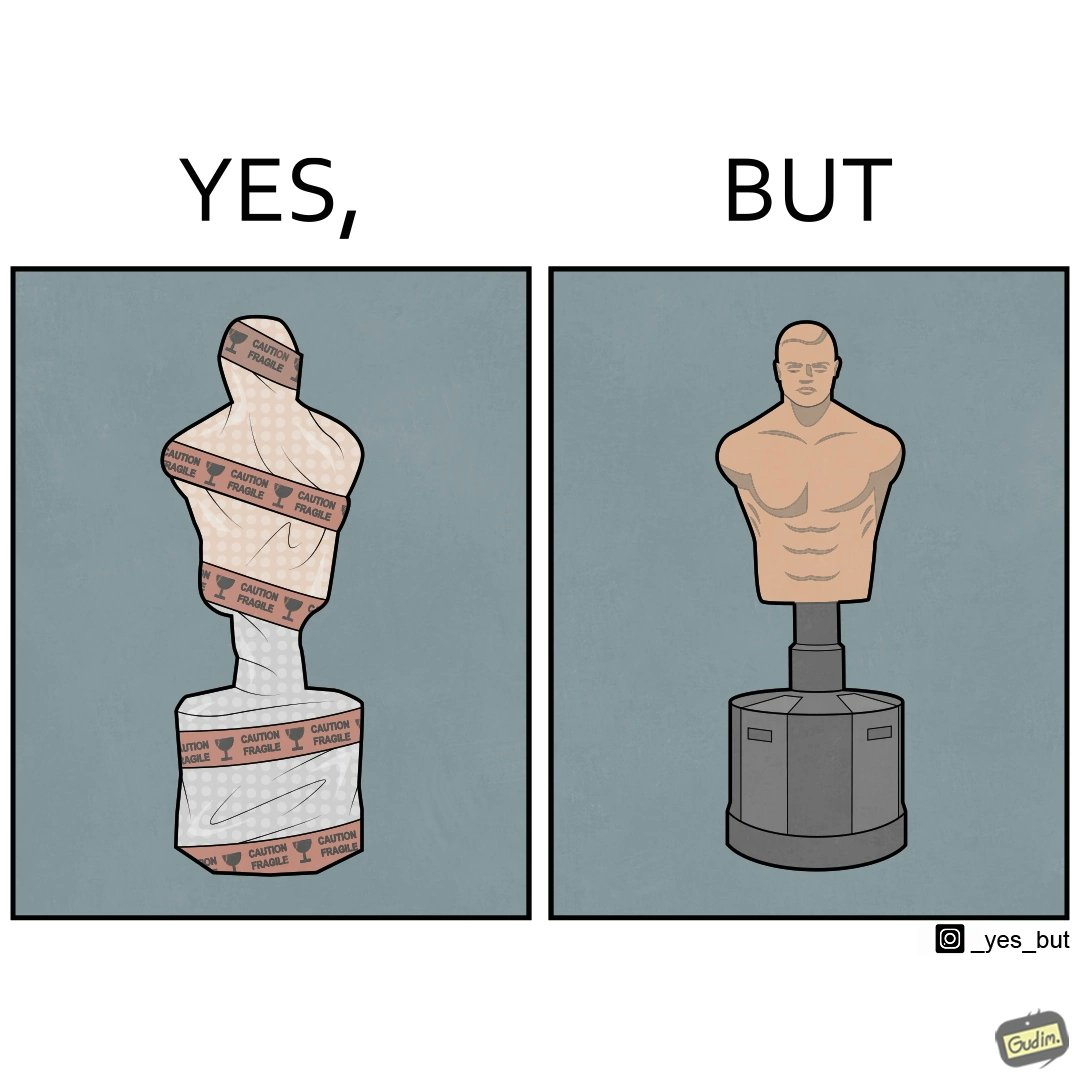Describe the content of this image. The image is funny because the object which is said to be fragile by the tape turns out to be an equipment to practice punches and kicks on meaning that it is very tought and sturdy. 